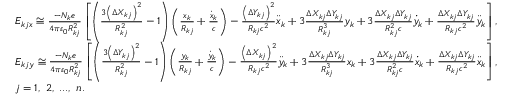Convert formula to latex. <formula><loc_0><loc_0><loc_500><loc_500>\begin{array} { r l } & { E _ { k j x } \cong \frac { - N _ { k } e } { 4 \pi \varepsilon _ { 0 } R _ { k j } ^ { 2 } } \left [ \left ( \frac { 3 \left ( \Delta X _ { k j } \right ) ^ { 2 } } { R _ { k j } ^ { 2 } } - 1 \right ) \left ( \frac { x _ { k } } { R _ { k j } } + \frac { \dot { x } _ { k } } { c } \right ) - \frac { \left ( \Delta Y _ { k j } \right ) ^ { 2 } } { R _ { k j } c ^ { 2 } } \ddot { x } _ { k } + 3 \frac { \Delta X _ { k j } \Delta Y _ { k j } } { R _ { k j } ^ { 3 } } y _ { k } + 3 \frac { \Delta X _ { k j } \Delta Y _ { k j } } { R _ { k j } ^ { 2 } c } \dot { y } _ { k } + \frac { \Delta X _ { k j } \Delta Y _ { k j } } { R _ { k j } c ^ { 2 } } \ddot { y } _ { k } \right ] , } \\ & { E _ { k j y } \cong \frac { - N _ { k } e } { 4 \pi \varepsilon _ { 0 } R _ { k j } ^ { 2 } } \left [ \left ( \frac { 3 \left ( \Delta Y _ { k j } \right ) ^ { 2 } } { R _ { k j } ^ { 2 } } - 1 \right ) \left ( \frac { y _ { k } } { R _ { k j } } + \frac { \dot { y } _ { k } } { c } \right ) - \frac { \left ( \Delta X _ { k j } \right ) ^ { 2 } } { R _ { k j } c ^ { 2 } } \ddot { y } _ { k } + 3 \frac { \Delta X _ { k j } \Delta Y _ { k j } } { R _ { k j } ^ { 3 } } x _ { k } + 3 \frac { \Delta X _ { k j } \Delta Y _ { k j } } { R _ { k j } ^ { 2 } c } \dot { x } _ { k } + \frac { \Delta X _ { k j } \Delta Y _ { k j } } { R _ { k j } c ^ { 2 } } \ddot { x } _ { k } \right ] , } \\ & { j = 1 , 2 , \dots , n . } \end{array}</formula> 